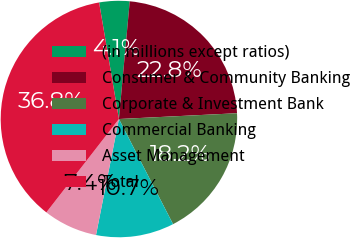Convert chart. <chart><loc_0><loc_0><loc_500><loc_500><pie_chart><fcel>(in millions except ratios)<fcel>Consumer & Community Banking<fcel>Corporate & Investment Bank<fcel>Commercial Banking<fcel>Asset Management<fcel>Total<nl><fcel>4.14%<fcel>22.76%<fcel>18.21%<fcel>10.67%<fcel>7.41%<fcel>36.8%<nl></chart> 